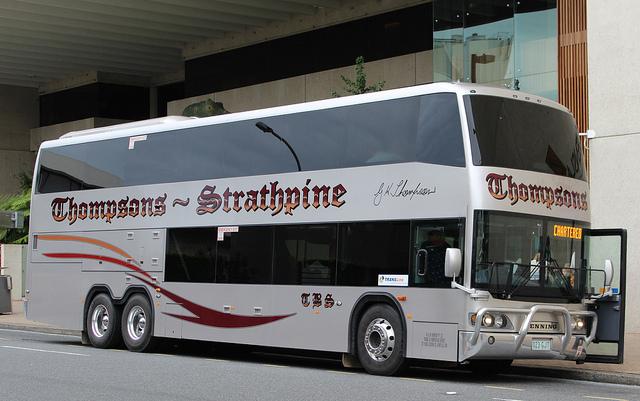What Color is the bus?
Answer briefly. White. What color is the front bumper on the bus?
Short answer required. Gray. How many levels does the bus have?
Quick response, please. 2. What is the first name on the bus?
Give a very brief answer. Thompsons. What company owns this bus?
Give a very brief answer. Thompsons. 